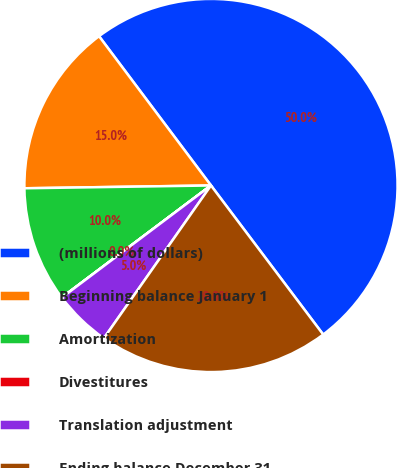Convert chart to OTSL. <chart><loc_0><loc_0><loc_500><loc_500><pie_chart><fcel>(millions of dollars)<fcel>Beginning balance January 1<fcel>Amortization<fcel>Divestitures<fcel>Translation adjustment<fcel>Ending balance December 31<nl><fcel>49.97%<fcel>15.0%<fcel>10.01%<fcel>0.01%<fcel>5.01%<fcel>20.0%<nl></chart> 